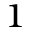<formula> <loc_0><loc_0><loc_500><loc_500>^ { 1 }</formula> 